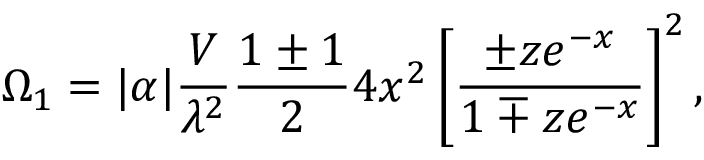<formula> <loc_0><loc_0><loc_500><loc_500>\Omega _ { 1 } = | \alpha | { \frac { V } { \lambda ^ { 2 } } } { \frac { 1 \pm 1 } { 2 } } 4 x ^ { 2 } \left [ { \frac { \pm z e ^ { - x } } { 1 \mp z e ^ { - x } } } \right ] ^ { 2 } ,</formula> 